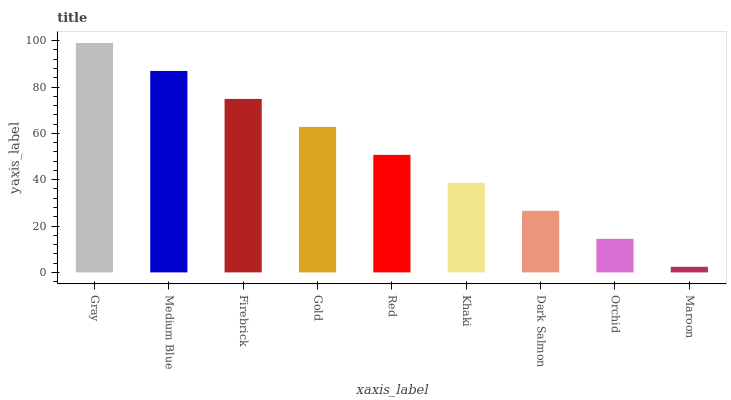Is Maroon the minimum?
Answer yes or no. Yes. Is Gray the maximum?
Answer yes or no. Yes. Is Medium Blue the minimum?
Answer yes or no. No. Is Medium Blue the maximum?
Answer yes or no. No. Is Gray greater than Medium Blue?
Answer yes or no. Yes. Is Medium Blue less than Gray?
Answer yes or no. Yes. Is Medium Blue greater than Gray?
Answer yes or no. No. Is Gray less than Medium Blue?
Answer yes or no. No. Is Red the high median?
Answer yes or no. Yes. Is Red the low median?
Answer yes or no. Yes. Is Gold the high median?
Answer yes or no. No. Is Khaki the low median?
Answer yes or no. No. 